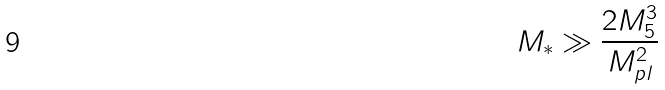Convert formula to latex. <formula><loc_0><loc_0><loc_500><loc_500>M _ { * } \gg \frac { 2 M _ { 5 } ^ { 3 } } { M _ { p l } ^ { 2 } }</formula> 